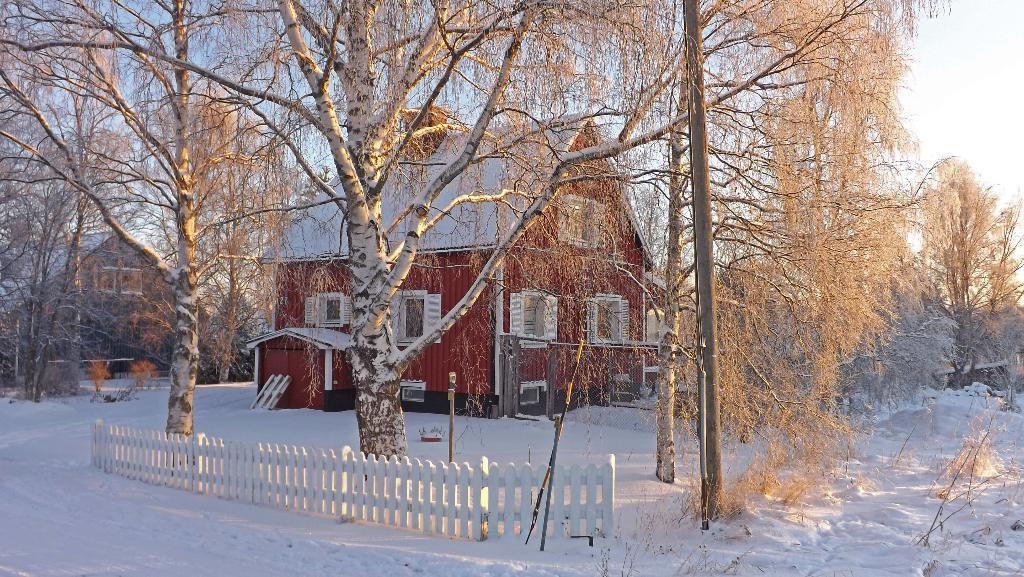What type of structures can be seen in the image? There are buildings in the image. What other objects can be seen in the image besides buildings? There are street poles, a fence, and trees visible in the image. What is visible in the background of the image? The sky is visible in the image. How is the road depicted in the image? The road is covered with snow in the image. What type of trick can be seen being performed on the street poles in the image? There is no trick being performed on the street poles in the image; they are simply standing upright. What type of territory is being claimed by the trees in the image? The trees in the image are not claiming any territory; they are simply growing in their natural environment. 